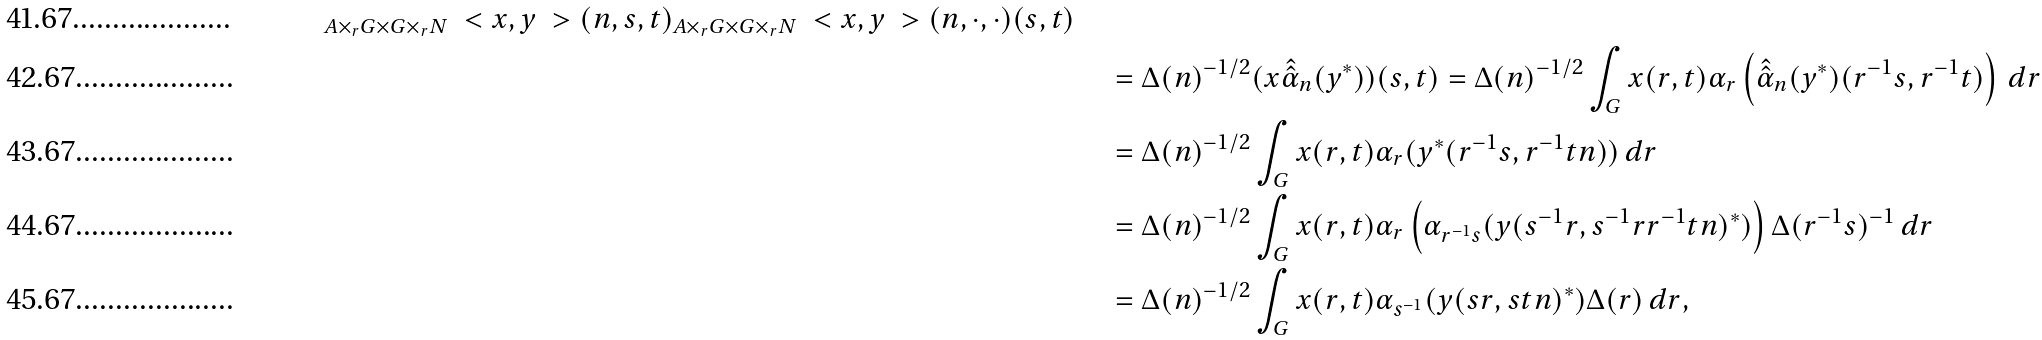Convert formula to latex. <formula><loc_0><loc_0><loc_500><loc_500>_ { A \times _ { r } G \times G \times _ { r } N } \ < x , y \ > ( n , s , t ) _ { A \times _ { r } G \times G \times _ { r } N } \ < x , y \ > ( n , \cdot , \cdot ) ( s , t ) \\ & \quad = \Delta ( n ) ^ { - 1 / 2 } ( x \hat { \hat { \alpha } } _ { n } ( y ^ { * } ) ) ( s , t ) = \Delta ( n ) ^ { - 1 / 2 } \int _ { G } x ( r , t ) \alpha _ { r } \left ( \hat { \hat { \alpha } } _ { n } ( y ^ { * } ) ( r ^ { - 1 } s , r ^ { - 1 } t ) \right ) \, d r \\ & \quad = \Delta ( n ) ^ { - 1 / 2 } \int _ { G } x ( r , t ) \alpha _ { r } ( y ^ { * } ( r ^ { - 1 } s , r ^ { - 1 } t n ) ) \, d r \\ & \quad = \Delta ( n ) ^ { - 1 / 2 } \int _ { G } x ( r , t ) \alpha _ { r } \left ( \alpha _ { r ^ { - 1 } s } ( y ( s ^ { - 1 } r , s ^ { - 1 } r r ^ { - 1 } t n ) ^ { * } ) \right ) \Delta ( r ^ { - 1 } s ) ^ { - 1 } \, d r \\ & \quad = \Delta ( n ) ^ { - 1 / 2 } \int _ { G } x ( r , t ) \alpha _ { s ^ { - 1 } } ( y ( s r , s t n ) ^ { * } ) \Delta ( r ) \, d r ,</formula> 